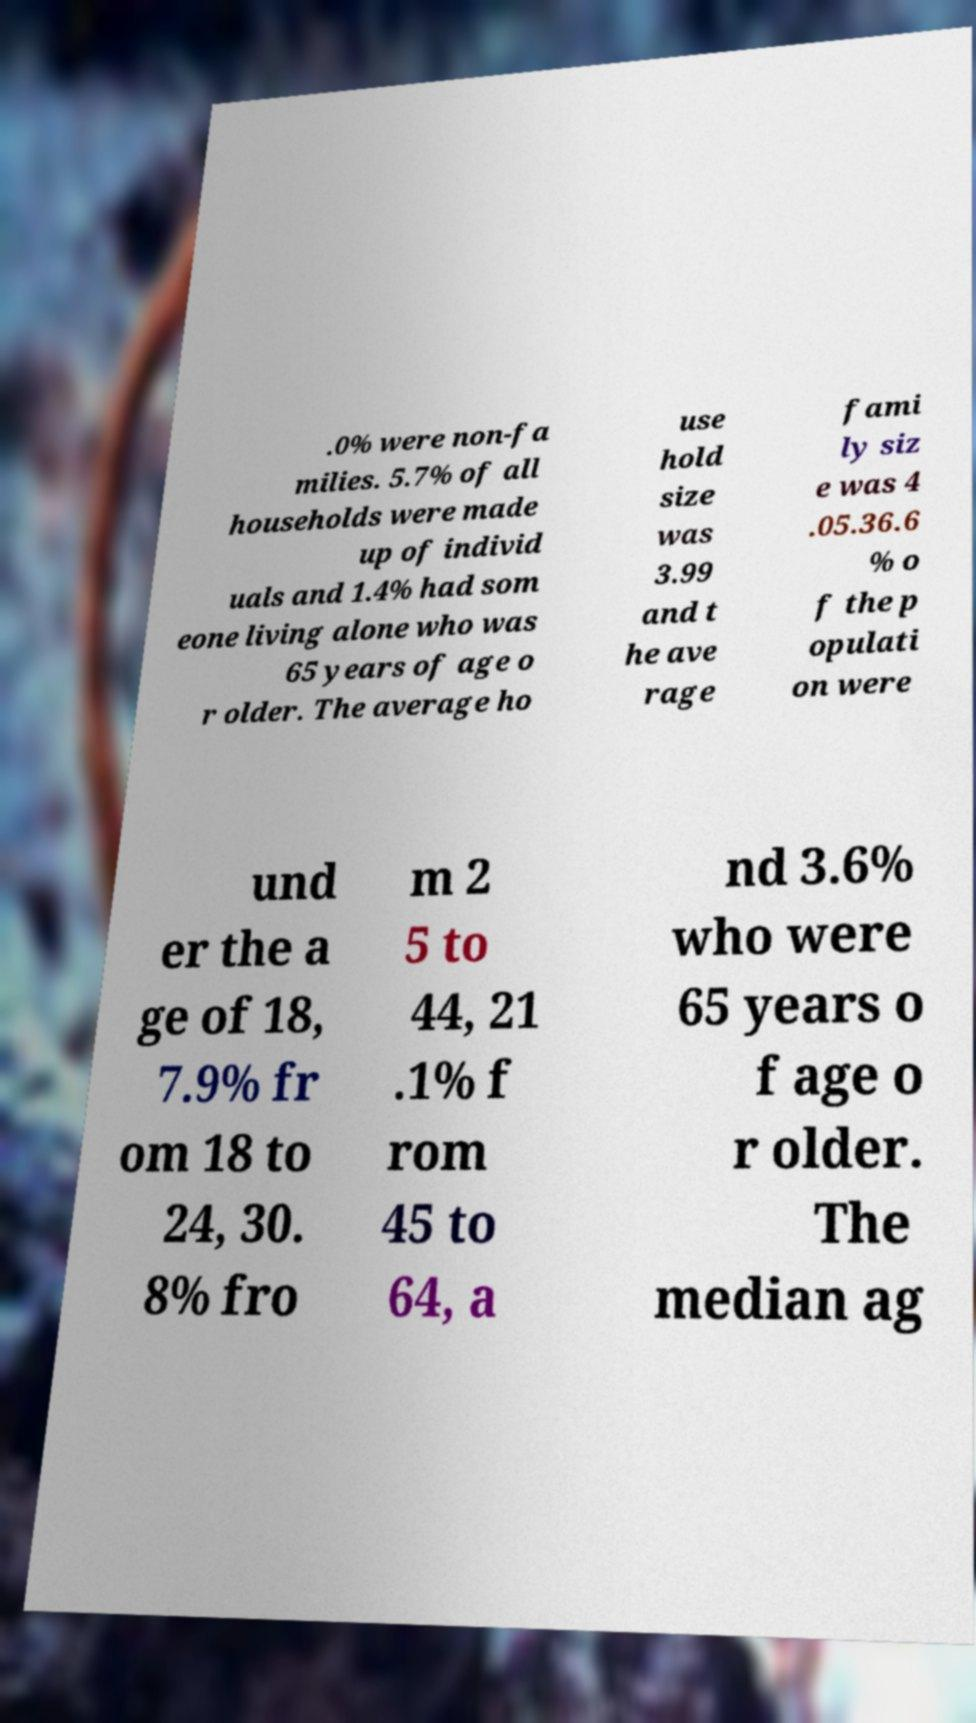I need the written content from this picture converted into text. Can you do that? .0% were non-fa milies. 5.7% of all households were made up of individ uals and 1.4% had som eone living alone who was 65 years of age o r older. The average ho use hold size was 3.99 and t he ave rage fami ly siz e was 4 .05.36.6 % o f the p opulati on were und er the a ge of 18, 7.9% fr om 18 to 24, 30. 8% fro m 2 5 to 44, 21 .1% f rom 45 to 64, a nd 3.6% who were 65 years o f age o r older. The median ag 